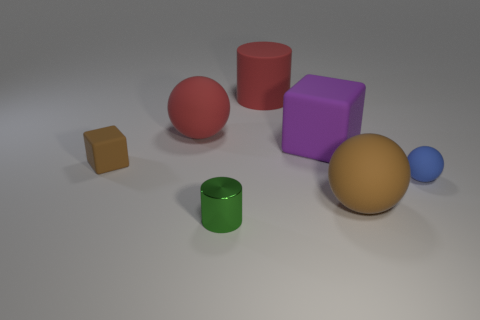What number of other things are the same size as the purple object? Upon examination of the objects in the image, it appears that three objects share a similar size to the purple cube: the red cylinder, the tan sphere, and the green cylinder. 